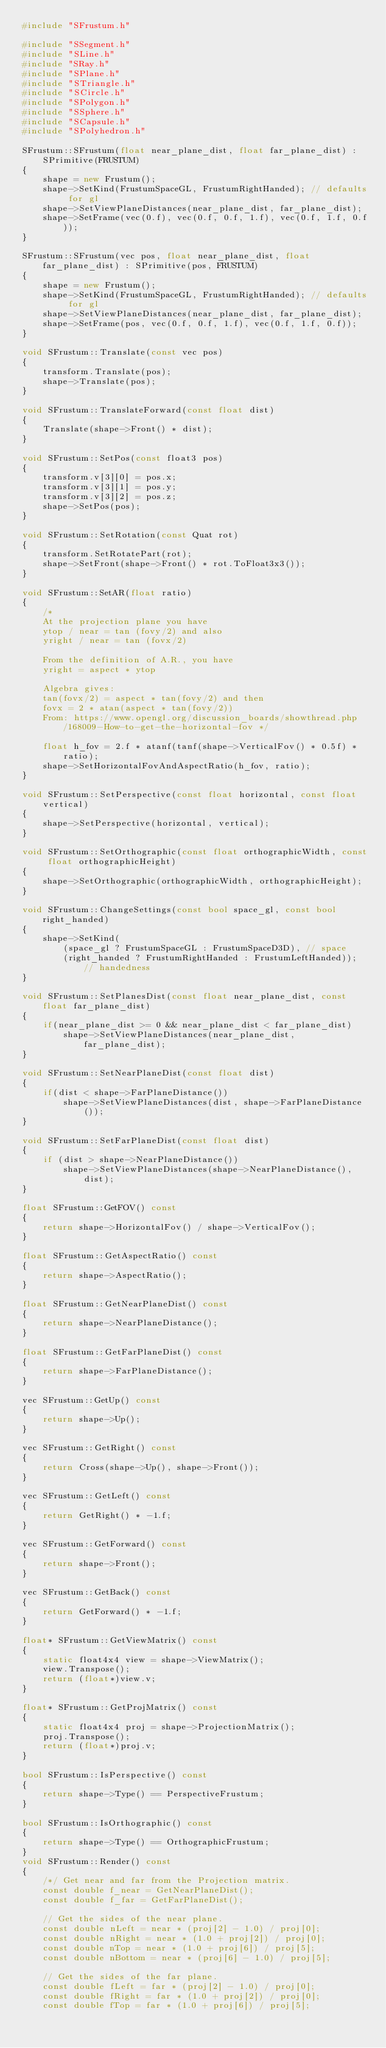<code> <loc_0><loc_0><loc_500><loc_500><_C++_>#include "SFrustum.h"

#include "SSegment.h"
#include "SLine.h"
#include "SRay.h"
#include "SPlane.h"
#include "STriangle.h"
#include "SCircle.h"
#include "SPolygon.h"
#include "SSphere.h"
#include "SCapsule.h"
#include "SPolyhedron.h"

SFrustum::SFrustum(float near_plane_dist, float far_plane_dist) : SPrimitive(FRUSTUM)
{
	shape = new Frustum();
	shape->SetKind(FrustumSpaceGL, FrustumRightHanded); // defaults for gl
	shape->SetViewPlaneDistances(near_plane_dist, far_plane_dist);
	shape->SetFrame(vec(0.f), vec(0.f, 0.f, 1.f), vec(0.f, 1.f, 0.f));
}

SFrustum::SFrustum(vec pos, float near_plane_dist, float far_plane_dist) : SPrimitive(pos, FRUSTUM)
{
	shape = new Frustum();
	shape->SetKind(FrustumSpaceGL, FrustumRightHanded); // defaults for gl
	shape->SetViewPlaneDistances(near_plane_dist, far_plane_dist);
	shape->SetFrame(pos, vec(0.f, 0.f, 1.f), vec(0.f, 1.f, 0.f));
}

void SFrustum::Translate(const vec pos)
{
	transform.Translate(pos);
	shape->Translate(pos);
}

void SFrustum::TranslateForward(const float dist)
{
	Translate(shape->Front() * dist);
}

void SFrustum::SetPos(const float3 pos)
{
	transform.v[3][0] = pos.x;
	transform.v[3][1] = pos.y;
	transform.v[3][2] = pos.z;
	shape->SetPos(pos);
}

void SFrustum::SetRotation(const Quat rot)
{
	transform.SetRotatePart(rot);
	shape->SetFront(shape->Front() * rot.ToFloat3x3());
}

void SFrustum::SetAR(float ratio)
{
	/* 
	At the projection plane you have
	ytop / near = tan (fovy/2) and also
	yright / near = tan (fovx/2)

	From the definition of A.R., you have
	yright = aspect * ytop

	Algebra gives:
	tan(fovx/2) = aspect * tan(fovy/2) and then
	fovx = 2 * atan(aspect * tan(fovy/2))
	From: https://www.opengl.org/discussion_boards/showthread.php/168009-How-to-get-the-horizontal-fov */

	float h_fov = 2.f * atanf(tanf(shape->VerticalFov() * 0.5f) * ratio);
	shape->SetHorizontalFovAndAspectRatio(h_fov, ratio);
}

void SFrustum::SetPerspective(const float horizontal, const float vertical)
{
	shape->SetPerspective(horizontal, vertical);
}

void SFrustum::SetOrthographic(const float orthographicWidth, const float orthographicHeight)
{
	shape->SetOrthographic(orthographicWidth, orthographicHeight);
}

void SFrustum::ChangeSettings(const bool space_gl, const bool right_handed)
{
	shape->SetKind(
		(space_gl ? FrustumSpaceGL : FrustumSpaceD3D), // space
		(right_handed ? FrustumRightHanded : FrustumLeftHanded)); // handedness
}

void SFrustum::SetPlanesDist(const float near_plane_dist, const float far_plane_dist)
{
	if(near_plane_dist >= 0 && near_plane_dist < far_plane_dist)
		shape->SetViewPlaneDistances(near_plane_dist, far_plane_dist);
}

void SFrustum::SetNearPlaneDist(const float dist)
{
	if(dist < shape->FarPlaneDistance())
		shape->SetViewPlaneDistances(dist, shape->FarPlaneDistance());
}

void SFrustum::SetFarPlaneDist(const float dist)
{
	if (dist > shape->NearPlaneDistance())
		shape->SetViewPlaneDistances(shape->NearPlaneDistance(), dist);
}

float SFrustum::GetFOV() const
{
	return shape->HorizontalFov() / shape->VerticalFov();
}

float SFrustum::GetAspectRatio() const
{
	return shape->AspectRatio();
}

float SFrustum::GetNearPlaneDist() const
{
	return shape->NearPlaneDistance();
}

float SFrustum::GetFarPlaneDist() const
{
	return shape->FarPlaneDistance();
}

vec SFrustum::GetUp() const
{
	return shape->Up();
}

vec SFrustum::GetRight() const
{
	return Cross(shape->Up(), shape->Front());
}

vec SFrustum::GetLeft() const
{
	return GetRight() * -1.f;
}

vec SFrustum::GetForward() const
{
	return shape->Front();
}

vec SFrustum::GetBack() const
{
	return GetForward() * -1.f;
}

float* SFrustum::GetViewMatrix() const
{
	static float4x4 view = shape->ViewMatrix();
	view.Transpose();
	return (float*)view.v;
}

float* SFrustum::GetProjMatrix() const
{
	static float4x4 proj = shape->ProjectionMatrix();
	proj.Transpose();
	return (float*)proj.v;
}

bool SFrustum::IsPerspective() const
{
	return shape->Type() == PerspectiveFrustum;
}

bool SFrustum::IsOrthographic() const
{
	return shape->Type() == OrthographicFrustum;
}
void SFrustum::Render() const
{
	/*/ Get near and far from the Projection matrix.
	const double f_near = GetNearPlaneDist();
	const double f_far = GetFarPlaneDist();

	// Get the sides of the near plane.
	const double nLeft = near * (proj[2] - 1.0) / proj[0];
	const double nRight = near * (1.0 + proj[2]) / proj[0];
	const double nTop = near * (1.0 + proj[6]) / proj[5];
	const double nBottom = near * (proj[6] - 1.0) / proj[5];

	// Get the sides of the far plane.
	const double fLeft = far * (proj[2] - 1.0) / proj[0];
	const double fRight = far * (1.0 + proj[2]) / proj[0];
	const double fTop = far * (1.0 + proj[6]) / proj[5];</code> 